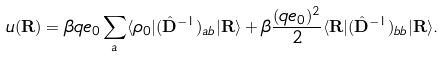Convert formula to latex. <formula><loc_0><loc_0><loc_500><loc_500>u ( { \mathbf R } ) = \beta q e _ { 0 } \sum _ { a } \langle \rho _ { 0 } | ( \hat { \mathbf D } ^ { - 1 } ) _ { a b } | { \mathbf R } \rangle + \beta \frac { ( q e _ { 0 } ) ^ { 2 } } { 2 } \langle { \mathbf R } | ( \hat { \mathbf D } ^ { - 1 } ) _ { b b } | { \mathbf R } \rangle .</formula> 